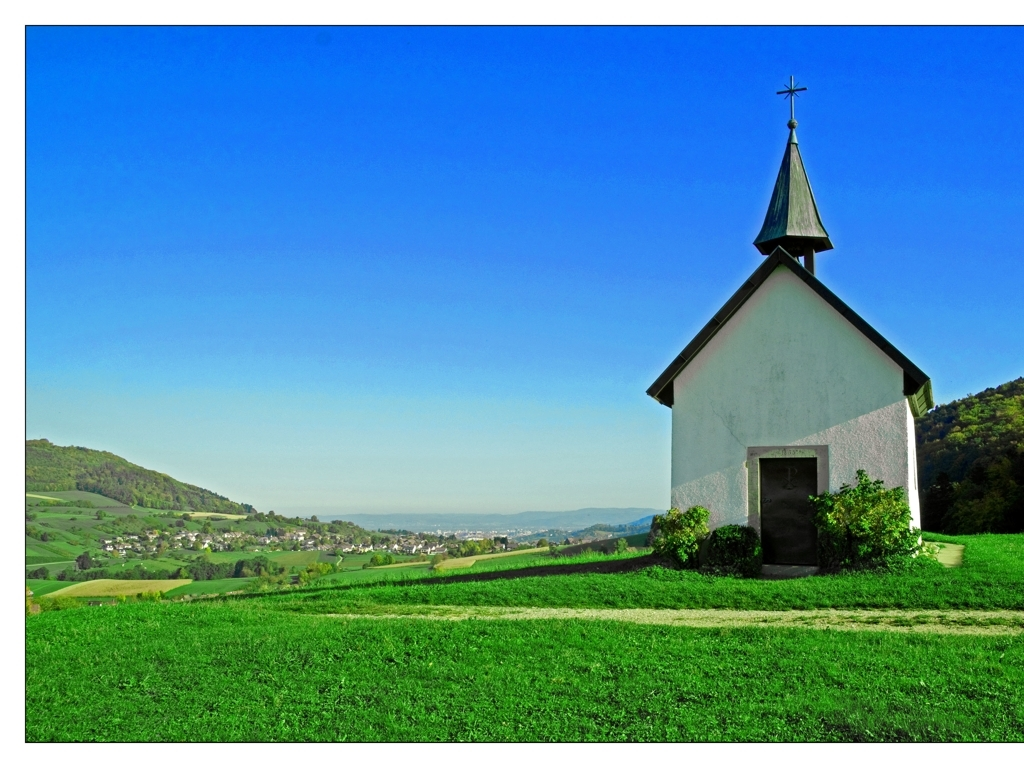Does the image have sufficient lighting? Yes, the image is well-lit with natural sunlight, highlighting the charming small chapel and the lush greenery surrounding it. The clear blue sky provides a vibrant backdrop, which further enhances the overall brightness and visibility of the scene. 